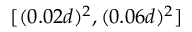Convert formula to latex. <formula><loc_0><loc_0><loc_500><loc_500>[ ( 0 . 0 2 d ) ^ { 2 } , ( 0 . 0 6 d ) ^ { 2 } ]</formula> 